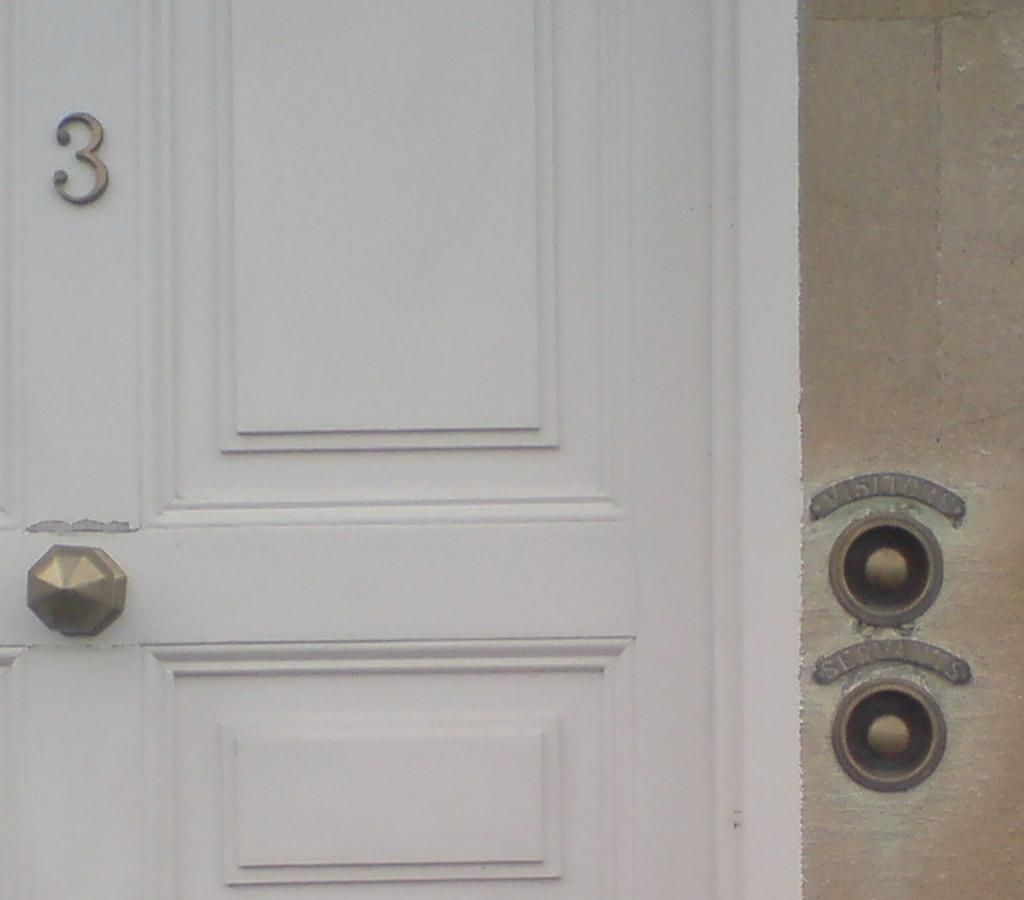What is the main object in the image? There is a door in the image. How is the door connected to the wall? The door is attached to a wall. Where is the knob located on the door? There is a knob on the left side of the door. What number is displayed above the door? There is a number "3" above the door. How many women are singing in harmony in the image? There are no women or singing in the image; it features a door with a knob and a number "3" above it. 